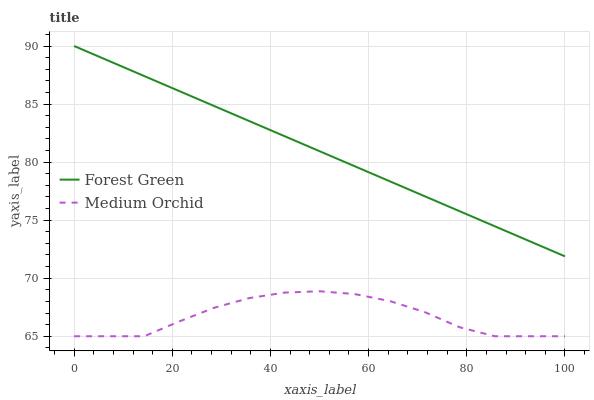Does Medium Orchid have the minimum area under the curve?
Answer yes or no. Yes. Does Forest Green have the maximum area under the curve?
Answer yes or no. Yes. Does Medium Orchid have the maximum area under the curve?
Answer yes or no. No. Is Forest Green the smoothest?
Answer yes or no. Yes. Is Medium Orchid the roughest?
Answer yes or no. Yes. Is Medium Orchid the smoothest?
Answer yes or no. No. Does Medium Orchid have the lowest value?
Answer yes or no. Yes. Does Forest Green have the highest value?
Answer yes or no. Yes. Does Medium Orchid have the highest value?
Answer yes or no. No. Is Medium Orchid less than Forest Green?
Answer yes or no. Yes. Is Forest Green greater than Medium Orchid?
Answer yes or no. Yes. Does Medium Orchid intersect Forest Green?
Answer yes or no. No. 